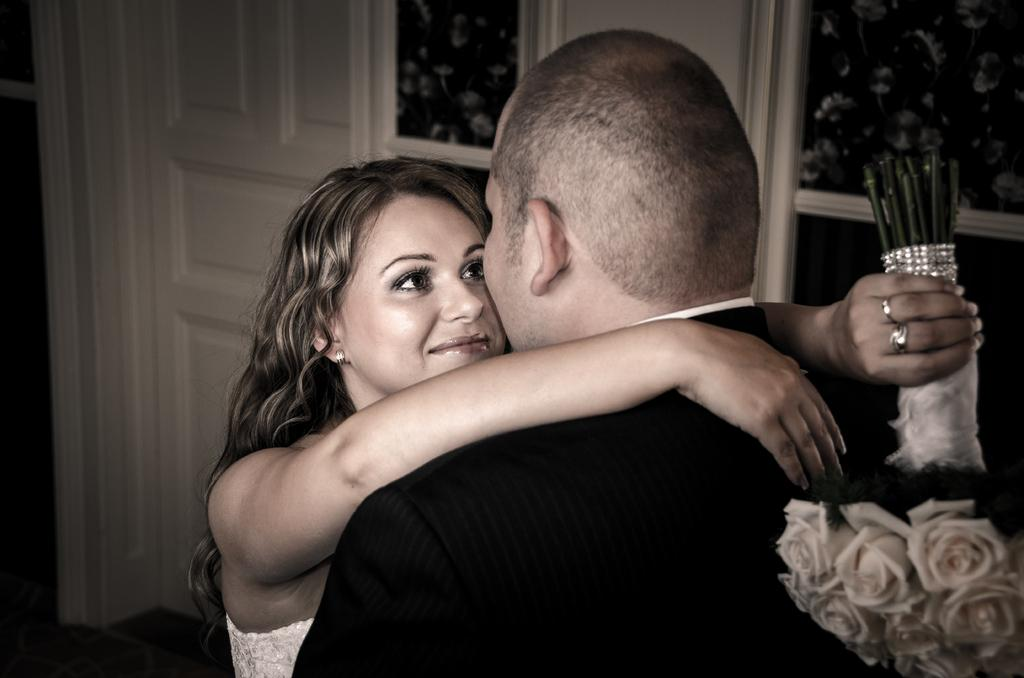How many people are in the image? There are two people in the image, a man and a woman. What are the man and woman doing in the image? The man and woman are holding each other. What is the woman holding in the image? The woman is holding a flower bouquet. What architectural features can be seen in the image? There is a door and windows visible in the image. What type of food is being served in the image? There is no food visible in the image. What class is the man teaching in the image? There is no indication of a class or teaching in the image. 